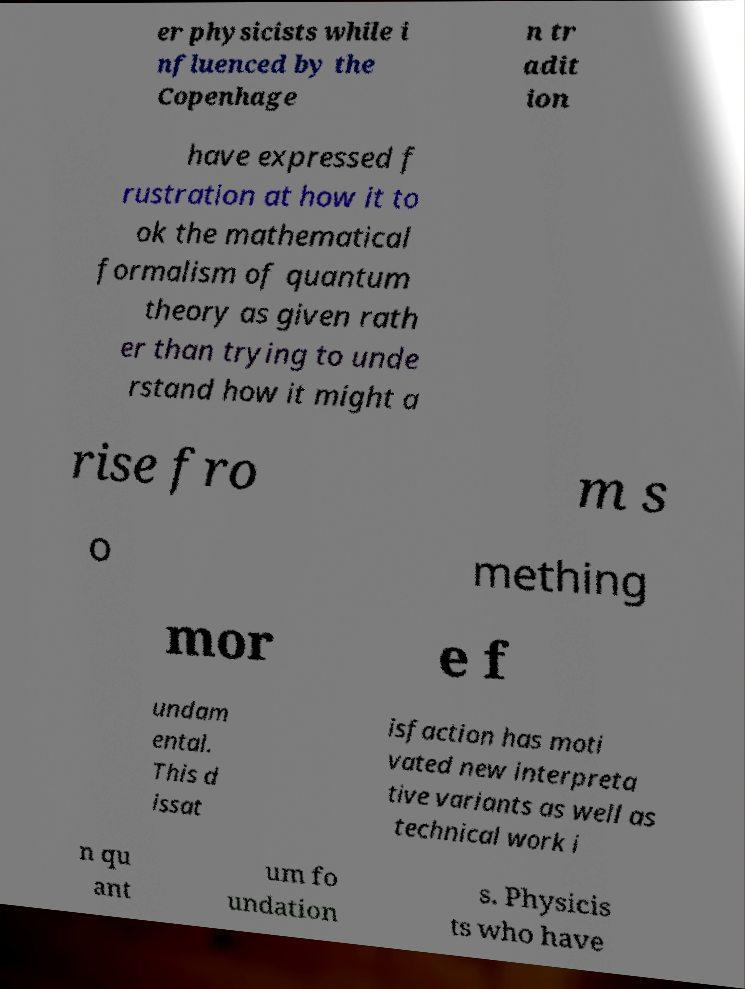Could you extract and type out the text from this image? er physicists while i nfluenced by the Copenhage n tr adit ion have expressed f rustration at how it to ok the mathematical formalism of quantum theory as given rath er than trying to unde rstand how it might a rise fro m s o mething mor e f undam ental. This d issat isfaction has moti vated new interpreta tive variants as well as technical work i n qu ant um fo undation s. Physicis ts who have 